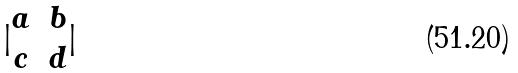Convert formula to latex. <formula><loc_0><loc_0><loc_500><loc_500>| \begin{matrix} a & b \\ c & d \end{matrix} |</formula> 